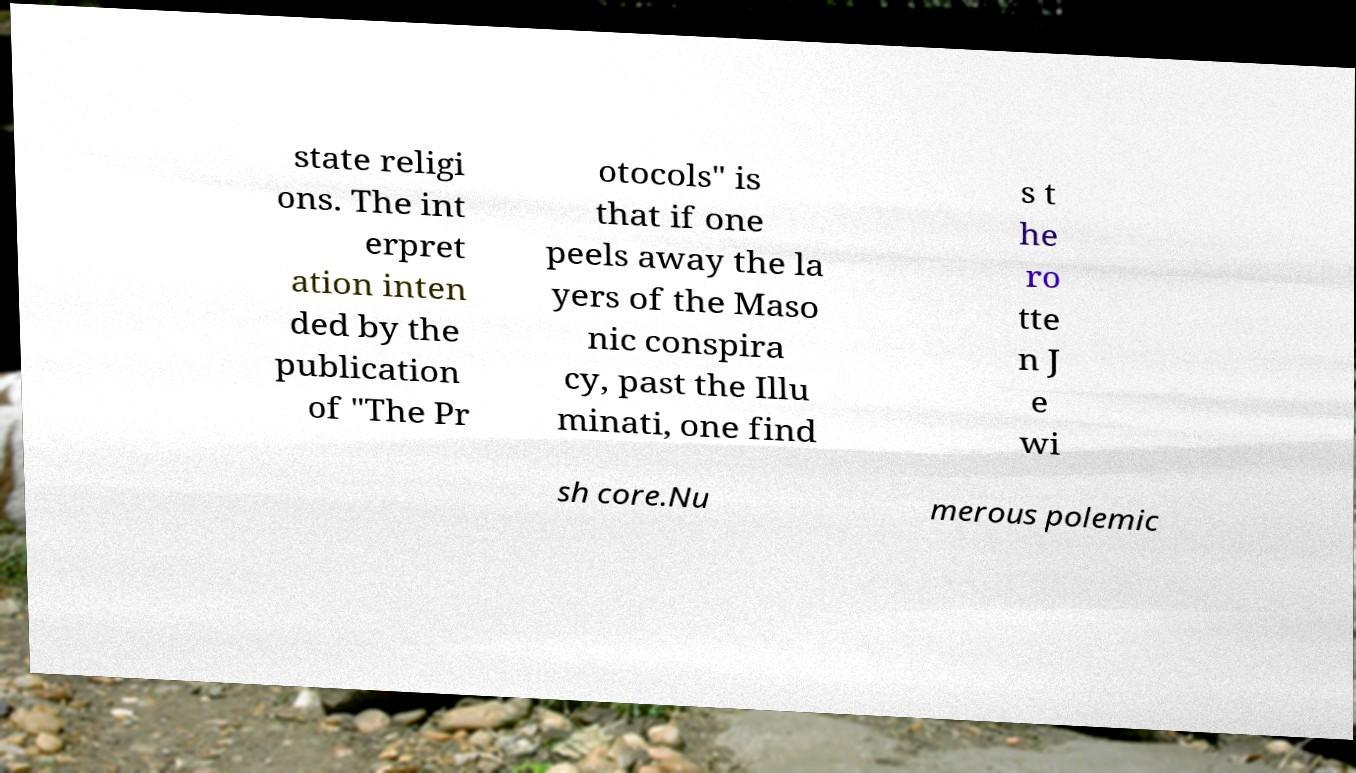Please read and relay the text visible in this image. What does it say? state religi ons. The int erpret ation inten ded by the publication of "The Pr otocols" is that if one peels away the la yers of the Maso nic conspira cy, past the Illu minati, one find s t he ro tte n J e wi sh core.Nu merous polemic 